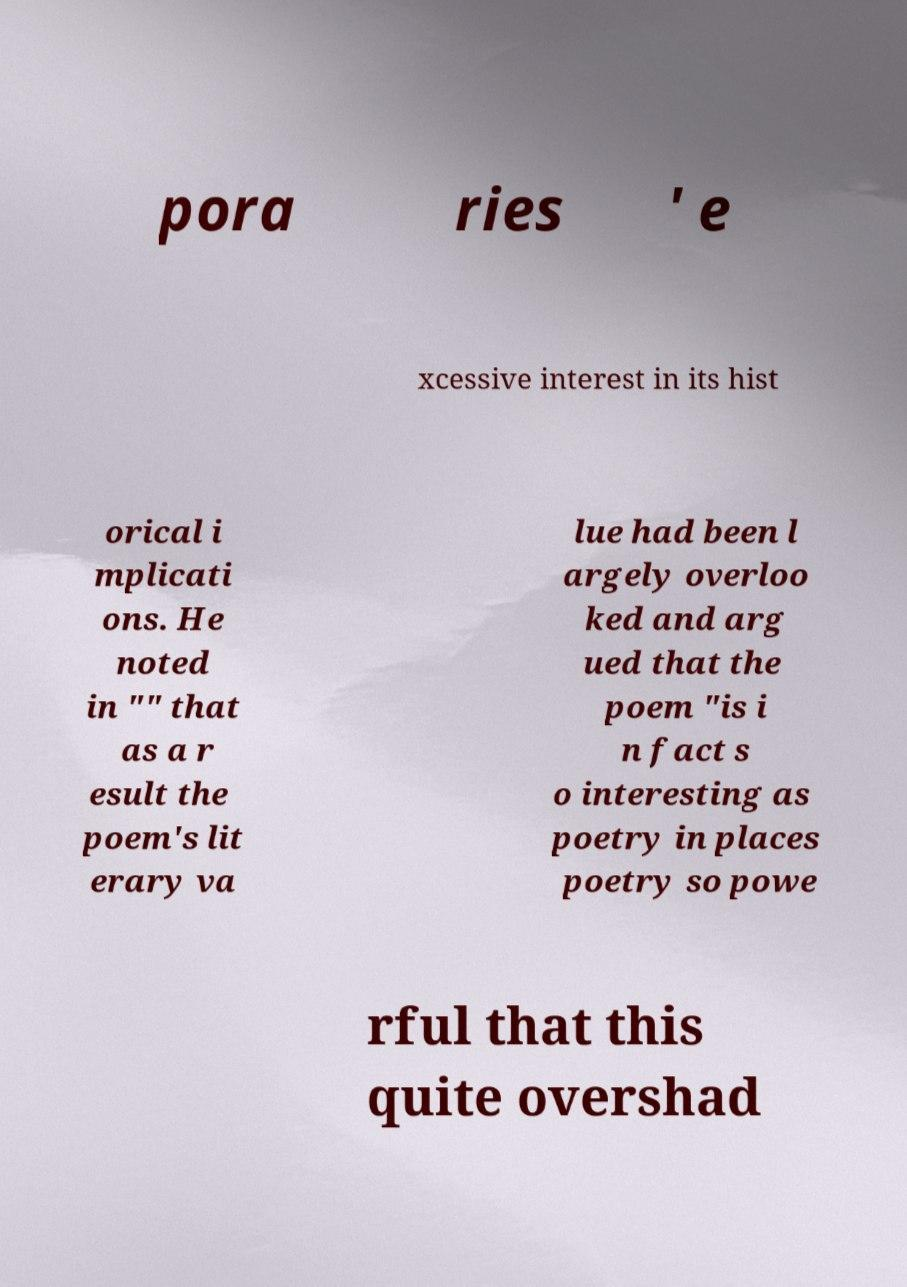Please identify and transcribe the text found in this image. pora ries ' e xcessive interest in its hist orical i mplicati ons. He noted in "" that as a r esult the poem's lit erary va lue had been l argely overloo ked and arg ued that the poem "is i n fact s o interesting as poetry in places poetry so powe rful that this quite overshad 